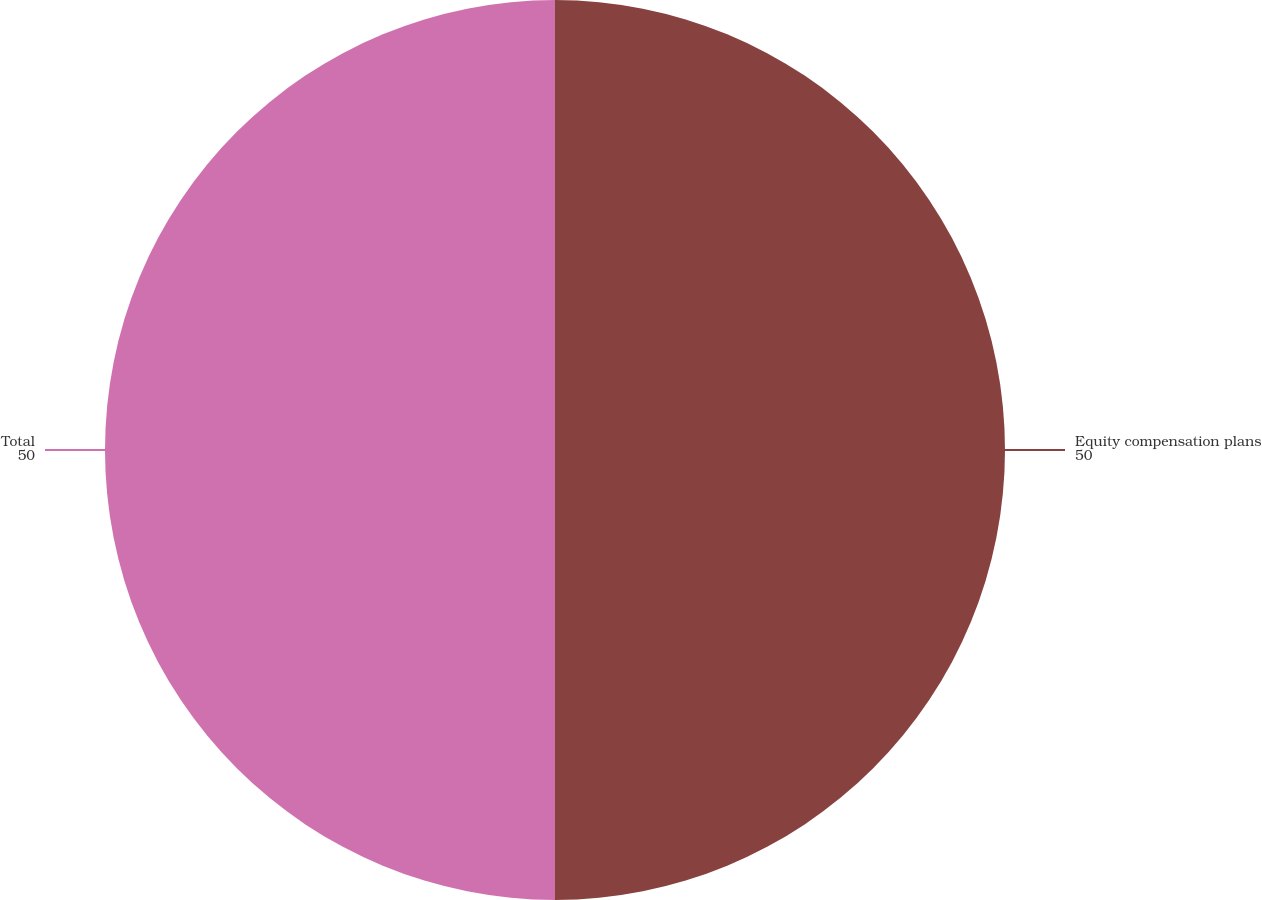<chart> <loc_0><loc_0><loc_500><loc_500><pie_chart><fcel>Equity compensation plans<fcel>Total<nl><fcel>50.0%<fcel>50.0%<nl></chart> 